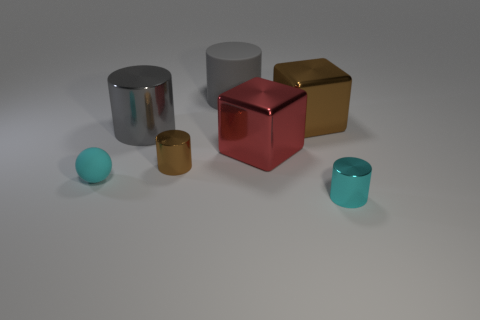There is a gray thing in front of the matte thing that is right of the tiny rubber sphere; are there any small brown metal cylinders that are on the right side of it? Yes, there is a single small brown metal cylinder situated to the right of the matte red cube, which is itself positioned to the right of the tiny rubber sphere. 